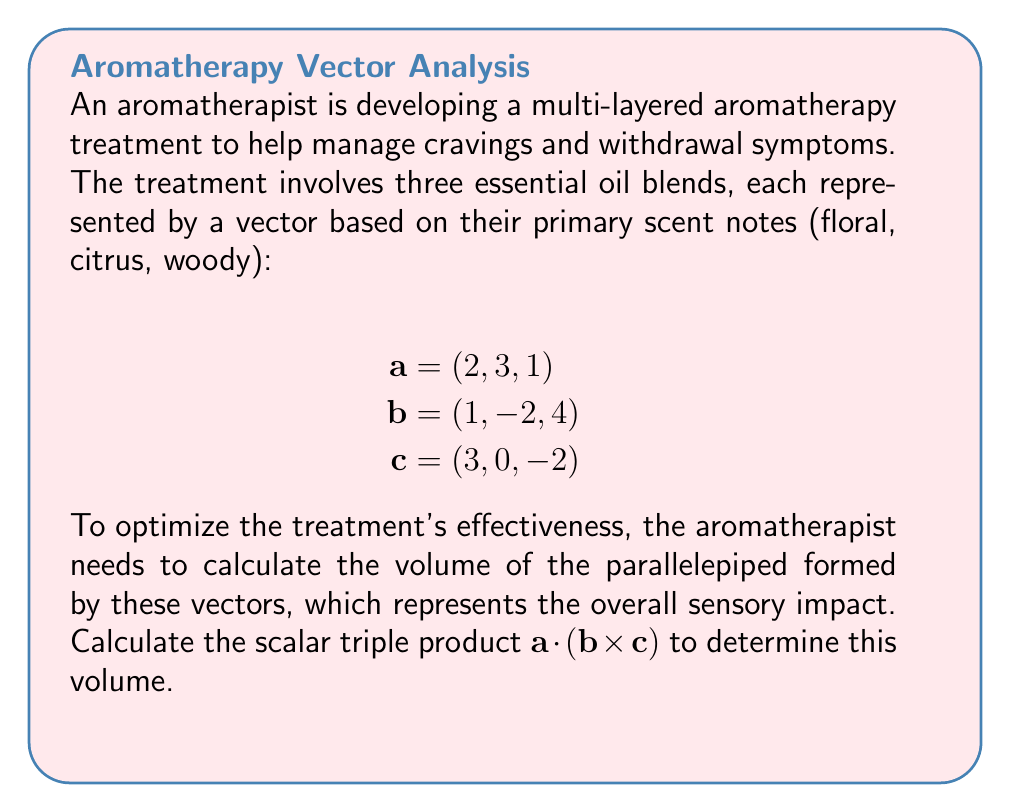Teach me how to tackle this problem. To calculate the scalar triple product $\mathbf{a} \cdot (\mathbf{b} \times \mathbf{c})$, we'll follow these steps:

1) First, calculate the cross product $\mathbf{b} \times \mathbf{c}$:

   $$\mathbf{b} \times \mathbf{c} = \begin{vmatrix} 
   \mathbf{i} & \mathbf{j} & \mathbf{k} \\
   1 & -2 & 4 \\
   3 & 0 & -2
   \end{vmatrix}$$

   $$= ((-2)(-2) - (4)(0))\mathbf{i} - ((1)(-2) - (4)(3))\mathbf{j} + ((1)(0) - (-2)(3))\mathbf{k}$$
   
   $$= 4\mathbf{i} - (-2 - 12)\mathbf{j} + 6\mathbf{k}$$
   
   $$= 4\mathbf{i} + 14\mathbf{j} + 6\mathbf{k}$$

2) Now, we have $\mathbf{b} \times \mathbf{c} = (4, 14, 6)$

3) Next, we calculate the dot product of $\mathbf{a}$ with this result:

   $$\mathbf{a} \cdot (\mathbf{b} \times \mathbf{c}) = (2, 3, 1) \cdot (4, 14, 6)$$

   $$= (2)(4) + (3)(14) + (1)(6)$$

   $$= 8 + 42 + 6$$

   $$= 56$$

4) The absolute value of this result, 56, represents the volume of the parallelepiped formed by the three vectors.
Answer: 56 cubic units 